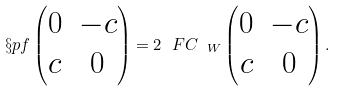<formula> <loc_0><loc_0><loc_500><loc_500>\S p f \begin{pmatrix} 0 & - c \\ c & 0 \end{pmatrix} = 2 \ F C _ { \ W } \begin{pmatrix} 0 & - c \\ c & 0 \end{pmatrix} .</formula> 